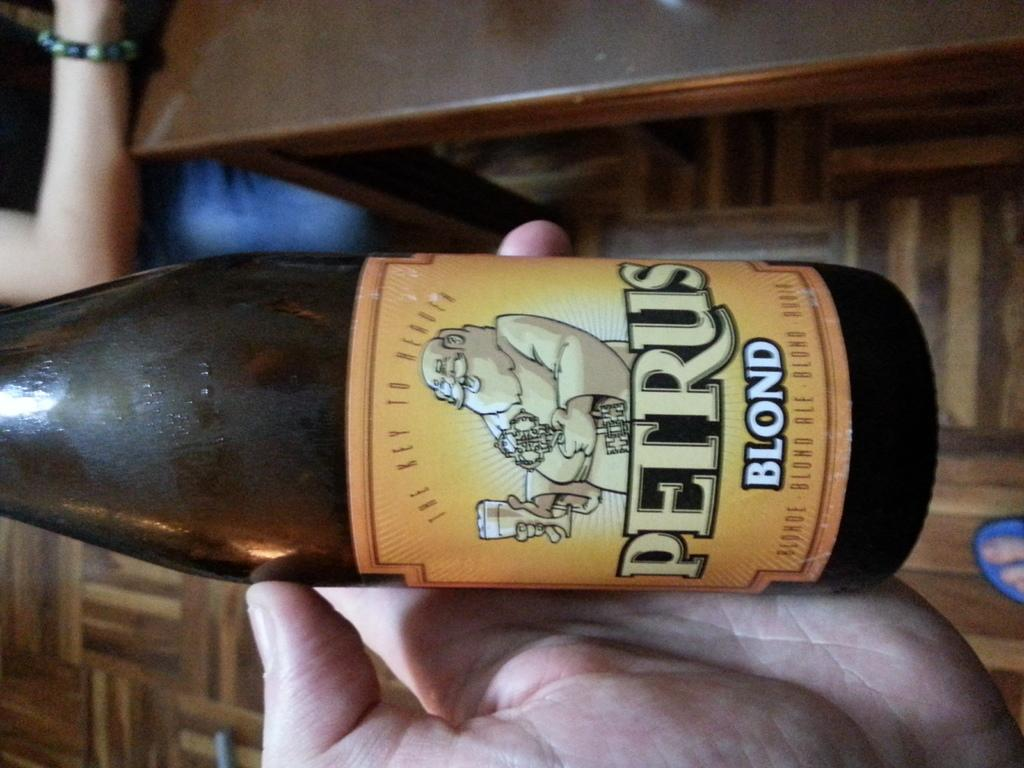<image>
Write a terse but informative summary of the picture. the word Petrus is on a beer bottle 